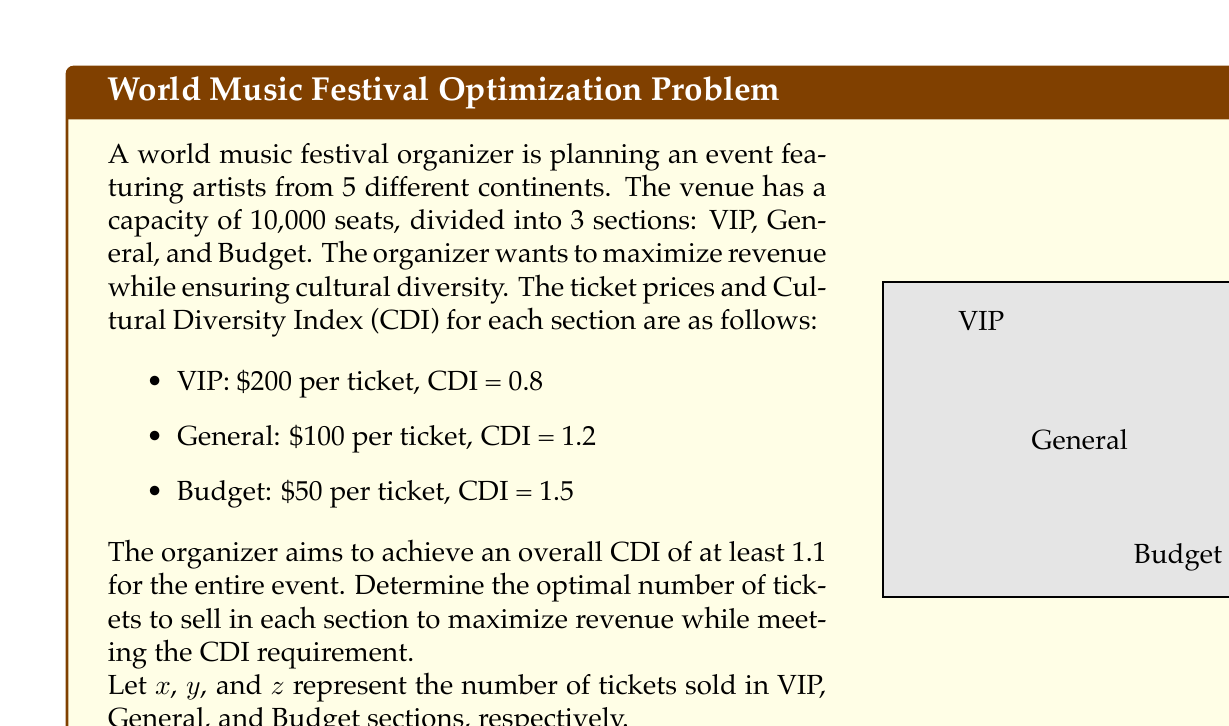Help me with this question. To solve this problem, we'll use linear programming:

1. Define the objective function:
   Maximize Revenue = $200x + 100y + 50z$

2. Set up constraints:
   a) Capacity constraint: $x + y + z \leq 10000$
   b) CDI constraint: $\frac{0.8x + 1.2y + 1.5z}{x + y + z} \geq 1.1$
   c) Non-negativity: $x, y, z \geq 0$

3. Simplify the CDI constraint:
   $0.8x + 1.2y + 1.5z \geq 1.1(x + y + z)$
   $0.8x + 1.2y + 1.5z \geq 1.1x + 1.1y + 1.1z$
   $-0.3x + 0.1y + 0.4z \geq 0$

4. The linear programming problem becomes:
   Maximize: $200x + 100y + 50z$
   Subject to:
   $x + y + z \leq 10000$
   $-0.3x + 0.1y + 0.4z \geq 0$
   $x, y, z \geq 0$

5. Solve using the simplex method or linear programming software.

6. The optimal solution is:
   $x = 2500$ (VIP tickets)
   $y = 7500$ (General tickets)
   $z = 0$ (Budget tickets)

7. Verify the solution:
   Revenue = $200(2500) + 100(7500) + 50(0) = 1,250,000$
   CDI = $\frac{0.8(2500) + 1.2(7500) + 1.5(0)}{2500 + 7500 + 0} = 1.1$

The solution maximizes revenue while meeting the CDI requirement of 1.1.
Answer: VIP: 2500, General: 7500, Budget: 0; Revenue: $1,250,000 